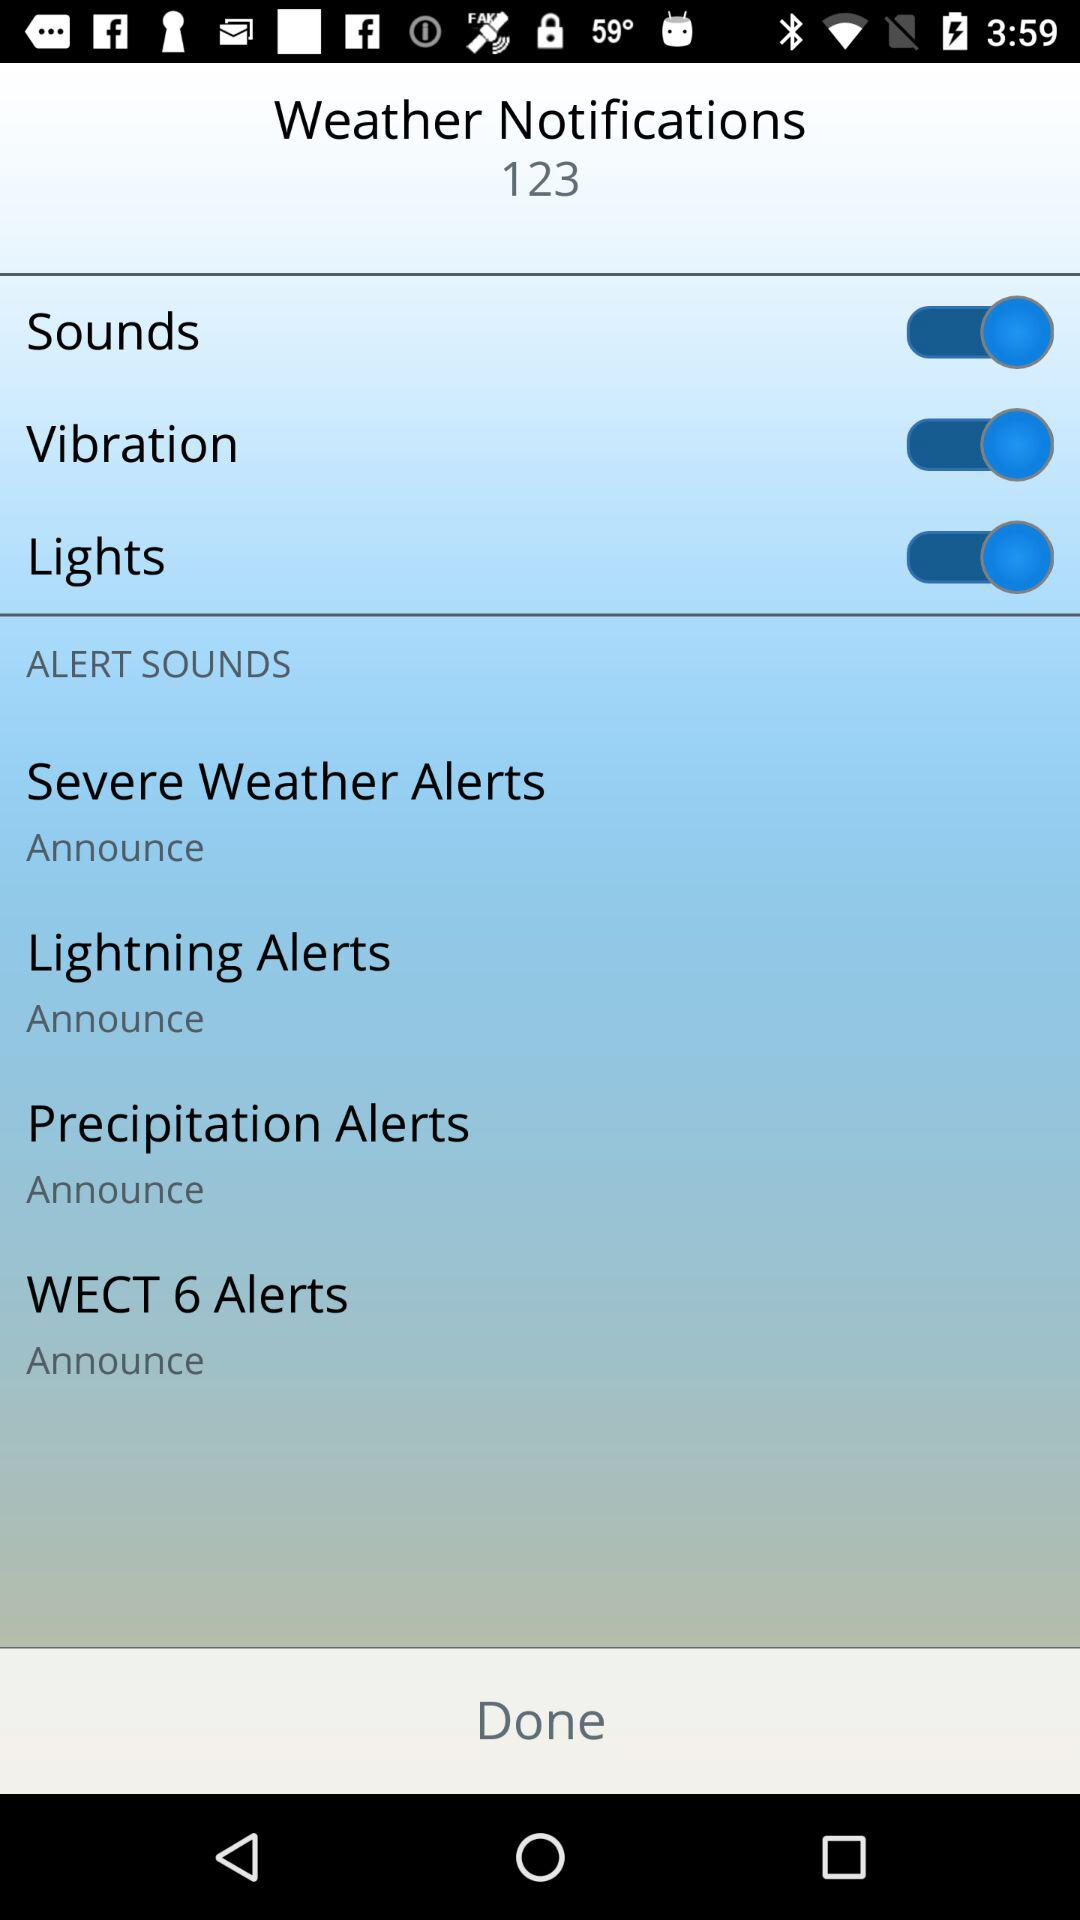What is the status of "Sounds"? The status is "on". 